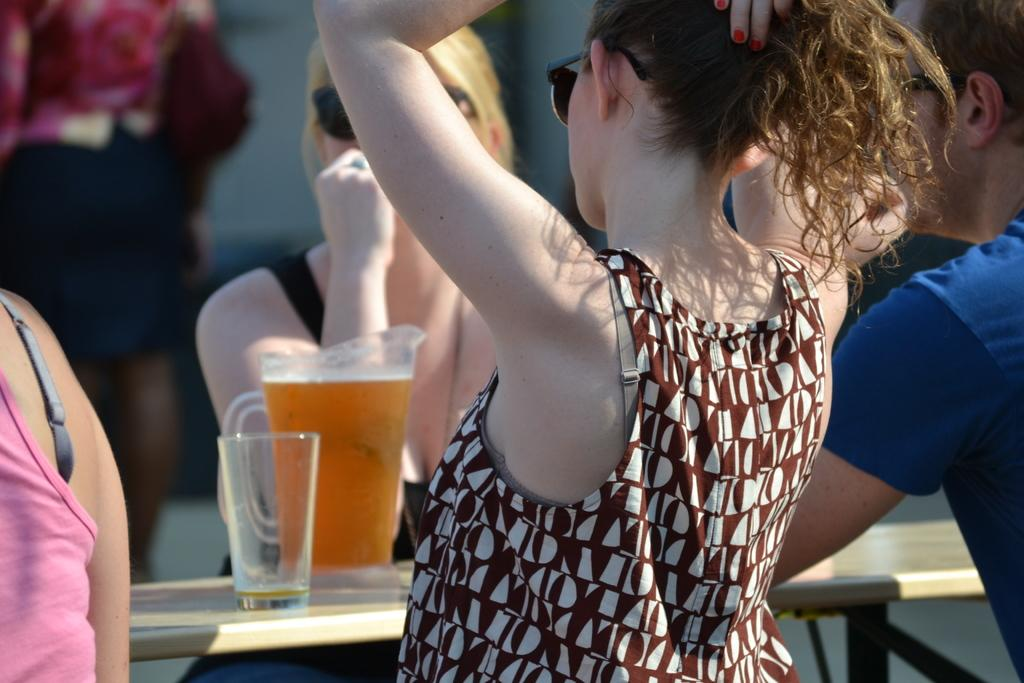How many people are in the image? There is a group of people in the image, but the exact number is not specified. What are the people in the image doing? Some people are sitting, while others are standing. What is on the table in front of the group? There is a table in front of the group, and on it, there is a glass and a jug with a drink. Can you describe the seating arrangement of the people in the image? The seating arrangement is not specified, but some people are sitting while others are standing. What type of lettuce is being used as a lipstick in the image? There is no lettuce or lipstick present in the image. Can you tell me how many alleys are visible in the image? There are no alleys visible in the image. 